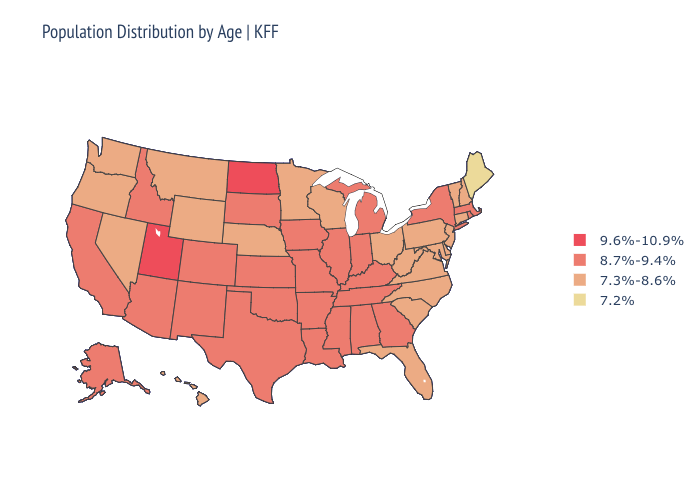What is the lowest value in the South?
Concise answer only. 7.3%-8.6%. Name the states that have a value in the range 9.6%-10.9%?
Give a very brief answer. North Dakota, Utah. Among the states that border Missouri , does Arkansas have the lowest value?
Concise answer only. No. Is the legend a continuous bar?
Answer briefly. No. Does Oklahoma have the lowest value in the USA?
Short answer required. No. Does the map have missing data?
Be succinct. No. Does Maine have the lowest value in the Northeast?
Concise answer only. Yes. Name the states that have a value in the range 7.2%?
Answer briefly. Maine. What is the value of California?
Short answer required. 8.7%-9.4%. Name the states that have a value in the range 7.2%?
Answer briefly. Maine. Is the legend a continuous bar?
Write a very short answer. No. Does North Dakota have the highest value in the USA?
Answer briefly. Yes. How many symbols are there in the legend?
Give a very brief answer. 4. Which states have the lowest value in the MidWest?
Concise answer only. Minnesota, Nebraska, Ohio, Wisconsin. 